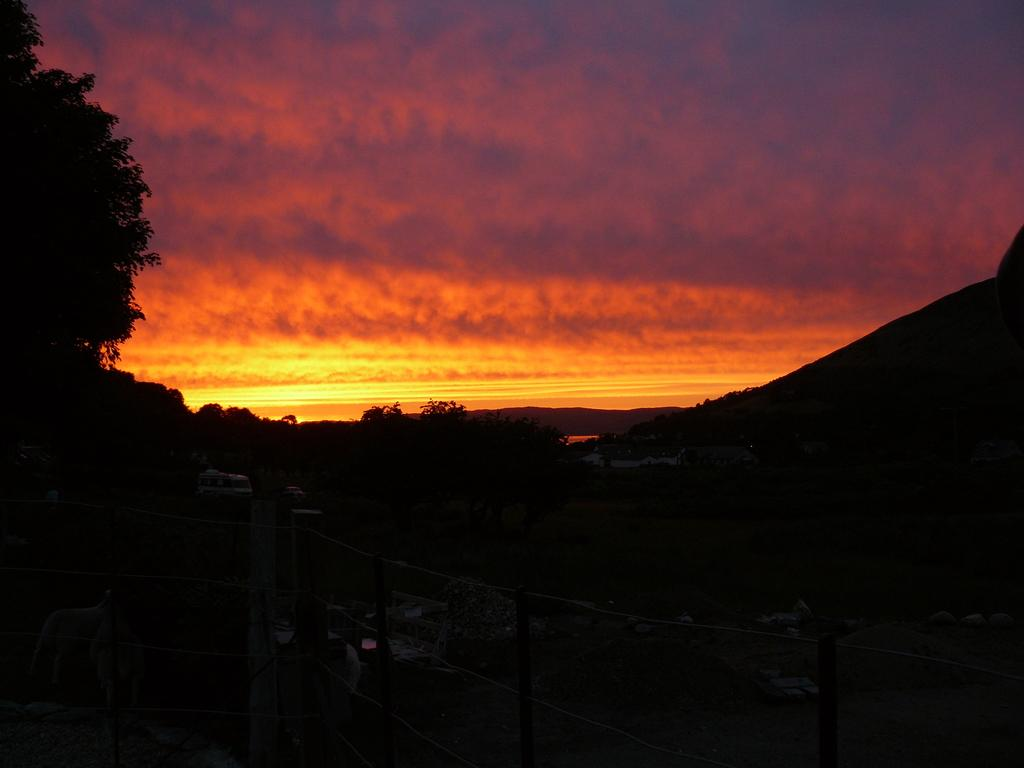What type of barrier can be seen in the image? There is a fence in the image. What else is present in the image besides the fence? There are vehicles, objects, trees, and mountains in the image. Can you describe the sky in the background of the image? The sky is visible in the background of the image, and there are clouds present. What type of wing is visible on the police officer in the image? There are no police officers or wings present in the image. What color is the scarf worn by the person in the image? There is no person wearing a scarf in the image. 